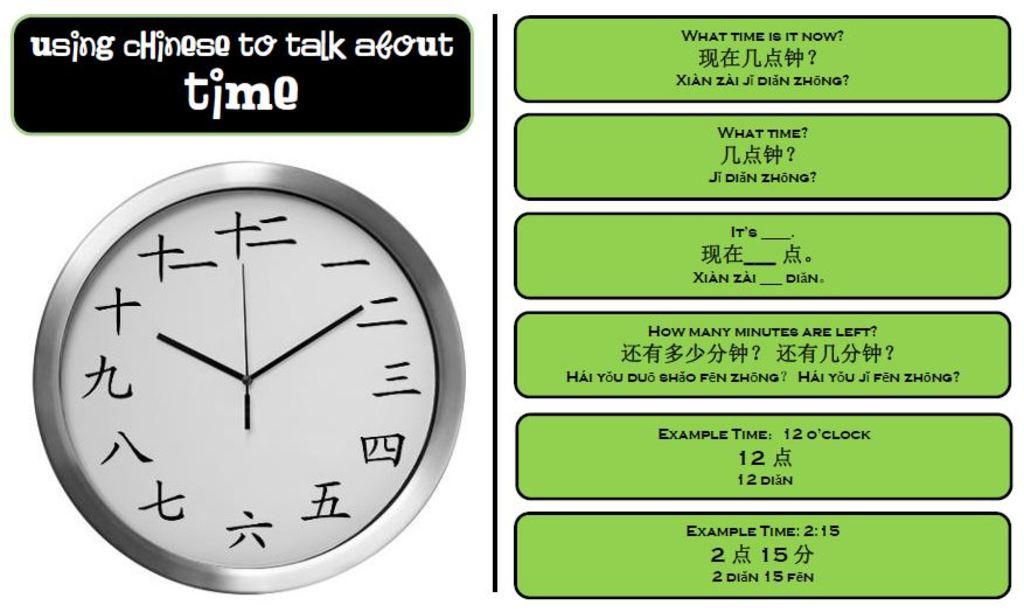What example time is on the right?
Your response must be concise. 2:15. 